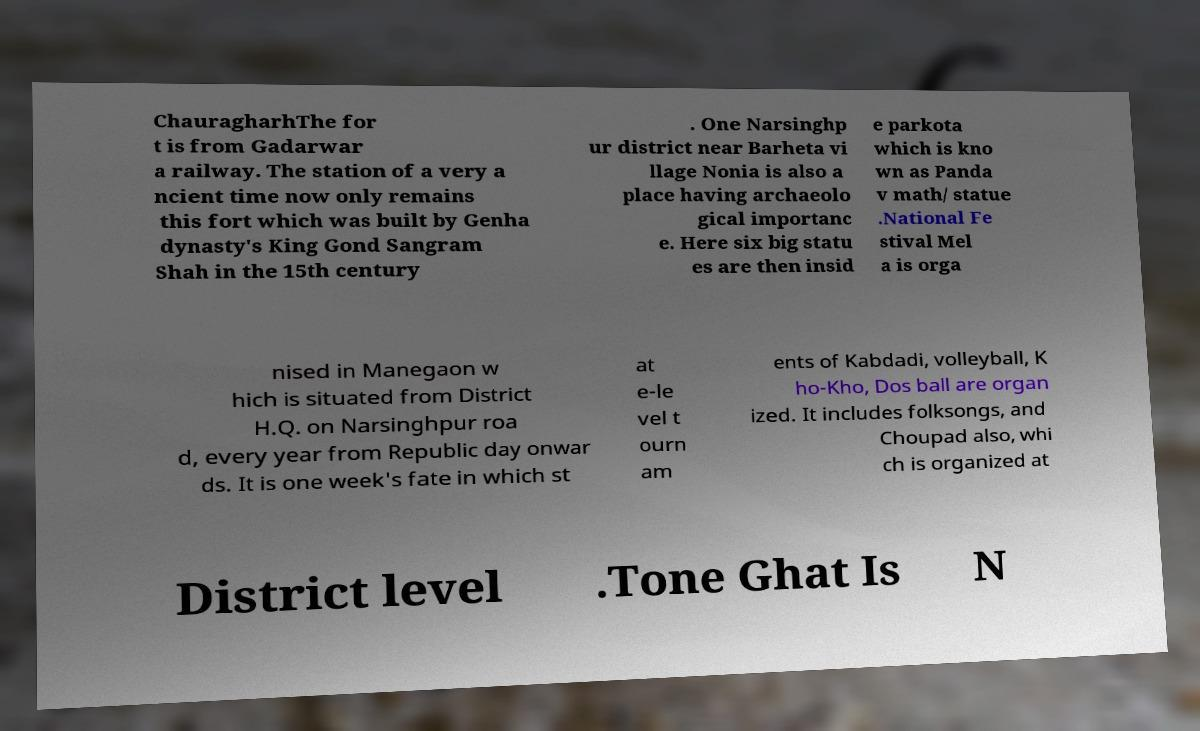I need the written content from this picture converted into text. Can you do that? ChauragharhThe for t is from Gadarwar a railway. The station of a very a ncient time now only remains this fort which was built by Genha dynasty's King Gond Sangram Shah in the 15th century . One Narsinghp ur district near Barheta vi llage Nonia is also a place having archaeolo gical importanc e. Here six big statu es are then insid e parkota which is kno wn as Panda v math/ statue .National Fe stival Mel a is orga nised in Manegaon w hich is situated from District H.Q. on Narsinghpur roa d, every year from Republic day onwar ds. It is one week's fate in which st at e-le vel t ourn am ents of Kabdadi, volleyball, K ho-Kho, Dos ball are organ ized. It includes folksongs, and Choupad also, whi ch is organized at District level .Tone Ghat Is N 